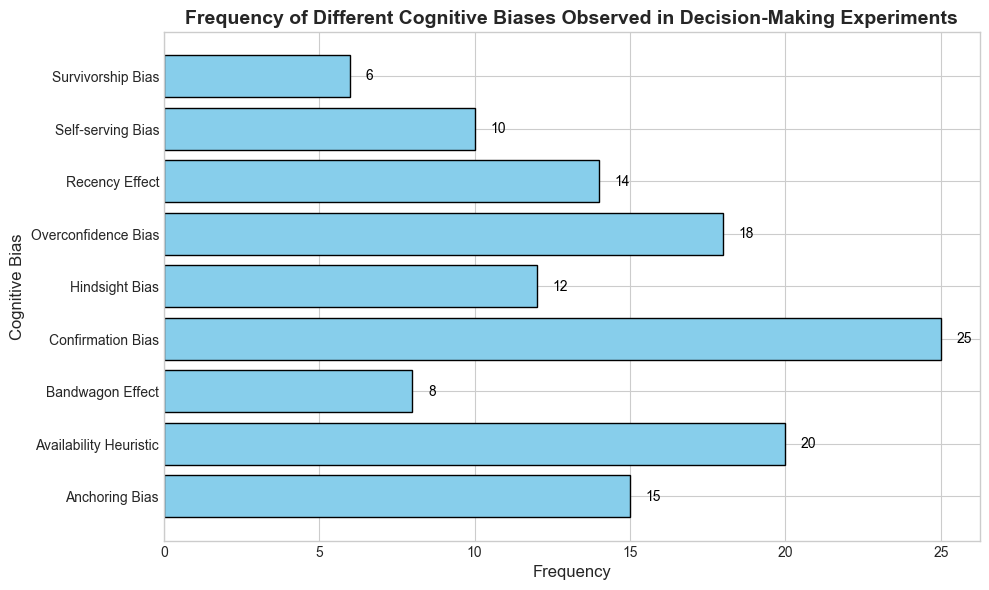Which cognitive bias has the highest frequency? To identify the cognitive bias with the highest frequency, look for the longest bar in the bar plot. The label corresponding to this bar will be the cognitive bias with the highest frequency. In this case, it is the "Confirmation Bias" with a frequency of 25.
Answer: Confirmation Bias What is the total frequency of "Anchoring Bias" and "Hindsight Bias"? Locate the bars corresponding to "Anchoring Bias" and "Hindsight Bias". Add their frequencies: 15 (Anchoring Bias) + 12 (Hindsight Bias) = 27.
Answer: 27 Which cognitive bias has the lowest observed frequency? Compare the lengths of all the bars in the histogram. The shortest bar represents the cognitive bias with the lowest frequency, which is "Survivorship Bias" with a frequency of 6.
Answer: Survivorship Bias How many cognitive biases have frequencies greater than 15? Count the number of bars whose lengths represent frequencies greater than 15. These bars correspond to "Confirmation Bias" (25), "Availability Heuristic" (20), and "Overconfidence Bias" (18), totaling 3 cognitive biases.
Answer: 3 What is the difference in frequency between "Recency Effect" and "Bandwagon Effect"? Find the lengths of the bars corresponding to "Recency Effect" and "Bandwagon Effect". Subtract the smaller number from the larger number: 14 (Recency Effect) - 8 (Bandwagon Effect) = 6.
Answer: 6 What is the combined frequency of "Self-serving Bias" and "Survivorship Bias"? Look at the bars corresponding to "Self-serving Bias" and "Survivorship Bias". Sum their frequencies: 10 (Self-serving Bias) + 6 (Survivorship Bias) = 16.
Answer: 16 Which cognitive biases have a frequency between 10 and 20? Identify the bars whose lengths fall within the range of 10 to 20. These bars represent the cognitive biases "Anchoring Bias" (15), "Hindsight Bias" (12), "Recency Effect" (14), and "Overconfidence Bias" (18).
Answer: Anchoring Bias, Hindsight Bias, Recency Effect, Overconfidence Bias How does the frequency of "Availability Heuristic" compare to "Self-serving Bias"? Compare the lengths of the two bars. "Availability Heuristic" (20) has a higher frequency than "Self-serving Bias" (10).
Answer: Availability Heuristic has a higher frequency What is the average frequency of the top three most observed cognitive biases? Identify the three longest bars: "Confirmation Bias" (25), "Availability Heuristic" (20), and "Overconfidence Bias" (18). Calculate the average: (25 + 20 + 18) / 3 = 21.
Answer: 21 What are the frequencies of "Anchoring Bias" and "Overconfidence Bias" combined? Add the frequencies of "Anchoring Bias" and "Overconfidence Bias": 15 (Anchoring Bias) + 18 (Overconfidence Bias) = 33.
Answer: 33 